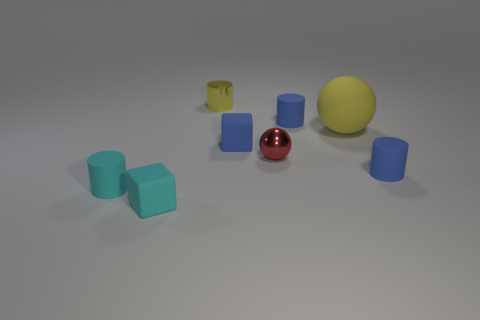Subtract all tiny yellow cylinders. How many cylinders are left? 3 Subtract all blocks. How many objects are left? 6 Subtract 2 cubes. How many cubes are left? 0 Subtract all small spheres. Subtract all tiny yellow rubber cubes. How many objects are left? 7 Add 7 tiny blue matte things. How many tiny blue matte things are left? 10 Add 3 big yellow metallic objects. How many big yellow metallic objects exist? 3 Add 1 large gray balls. How many objects exist? 9 Subtract all cyan blocks. How many blocks are left? 1 Subtract 0 gray blocks. How many objects are left? 8 Subtract all red balls. Subtract all cyan blocks. How many balls are left? 1 